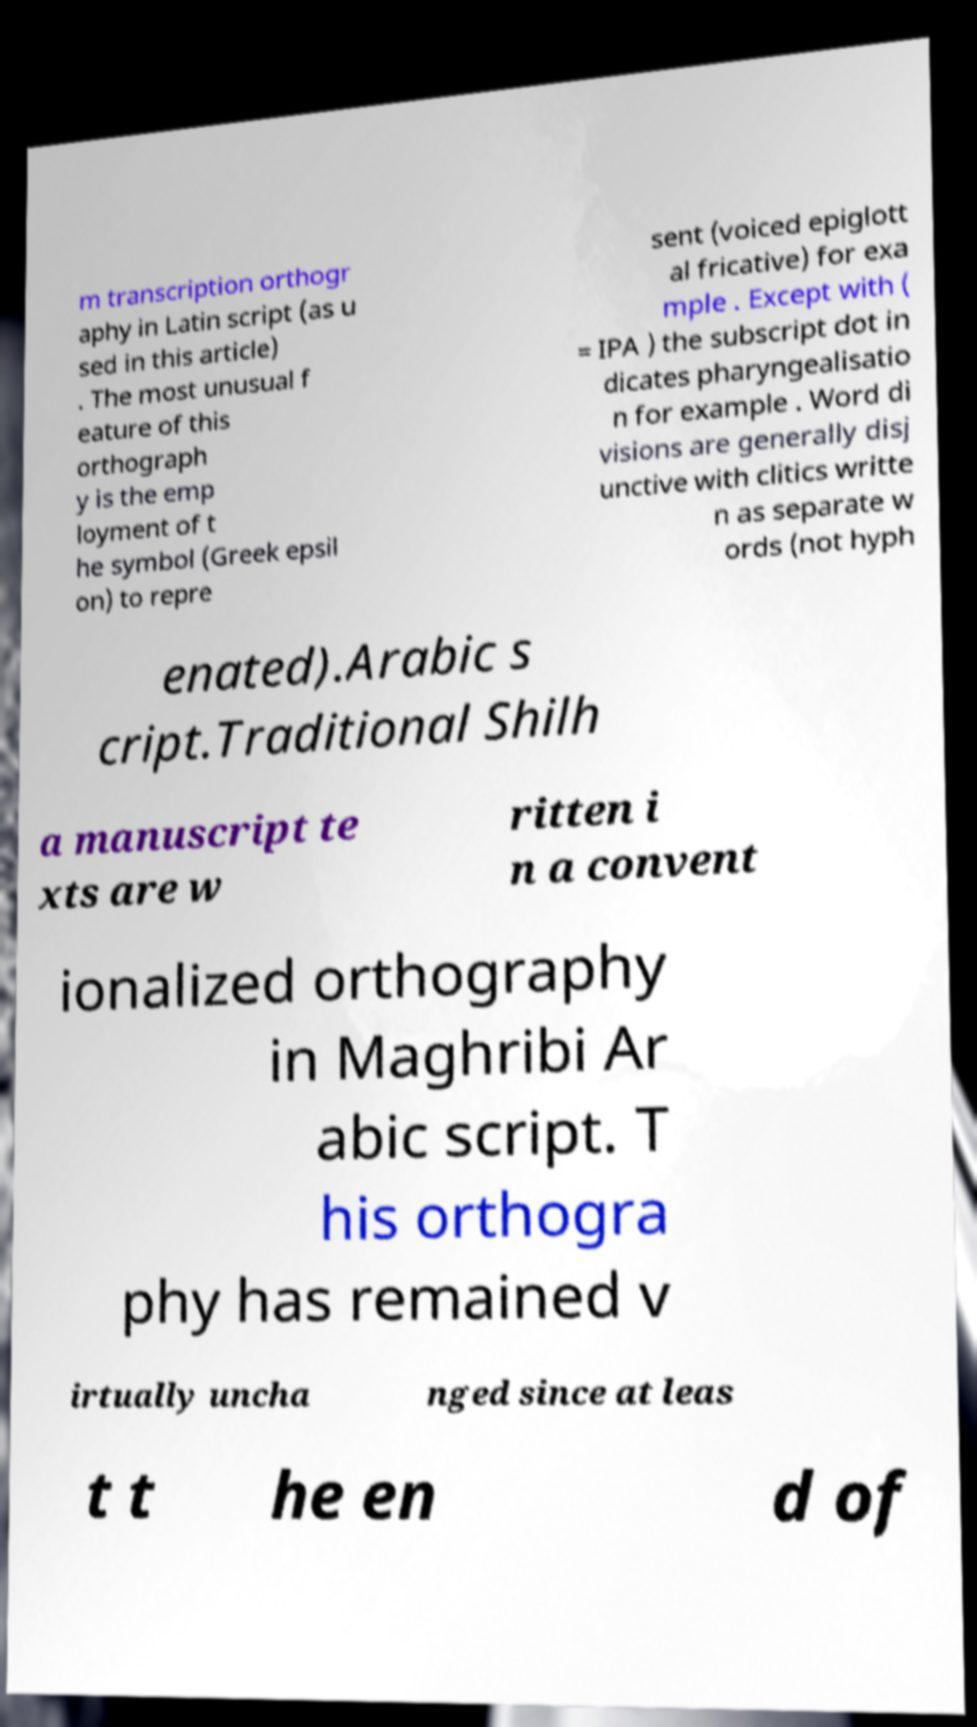For documentation purposes, I need the text within this image transcribed. Could you provide that? m transcription orthogr aphy in Latin script (as u sed in this article) . The most unusual f eature of this orthograph y is the emp loyment of t he symbol (Greek epsil on) to repre sent (voiced epiglott al fricative) for exa mple . Except with ( = IPA ) the subscript dot in dicates pharyngealisatio n for example . Word di visions are generally disj unctive with clitics writte n as separate w ords (not hyph enated).Arabic s cript.Traditional Shilh a manuscript te xts are w ritten i n a convent ionalized orthography in Maghribi Ar abic script. T his orthogra phy has remained v irtually uncha nged since at leas t t he en d of 